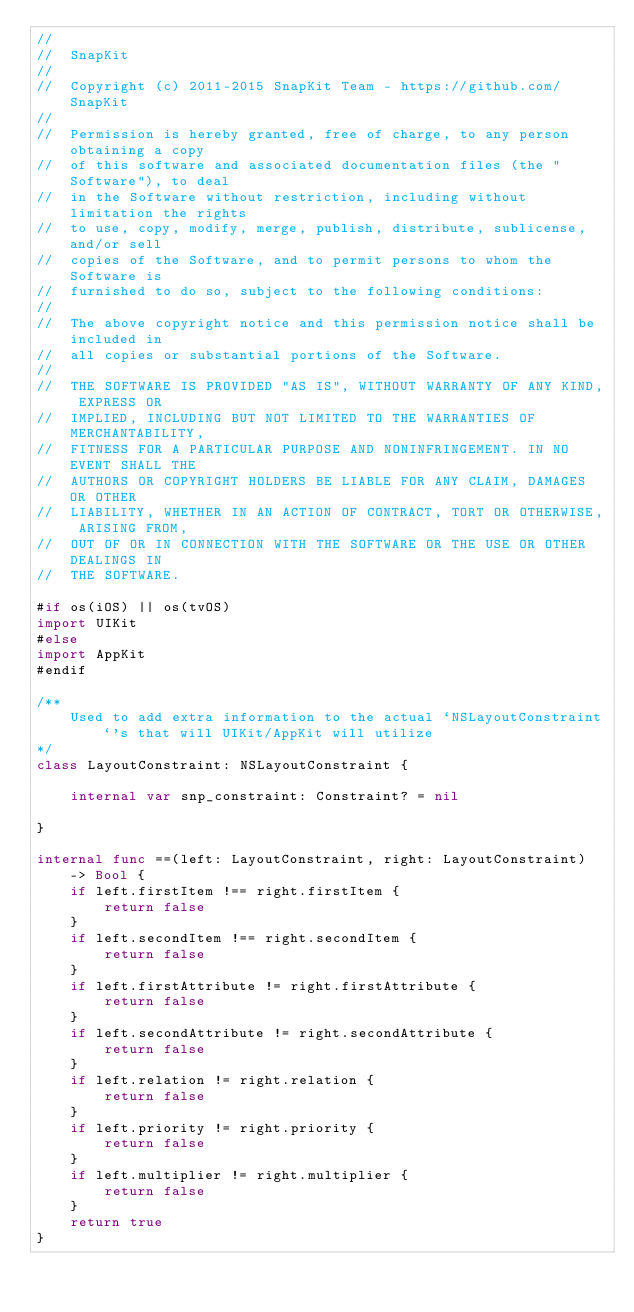Convert code to text. <code><loc_0><loc_0><loc_500><loc_500><_Swift_>//
//  SnapKit
//
//  Copyright (c) 2011-2015 SnapKit Team - https://github.com/SnapKit
//
//  Permission is hereby granted, free of charge, to any person obtaining a copy
//  of this software and associated documentation files (the "Software"), to deal
//  in the Software without restriction, including without limitation the rights
//  to use, copy, modify, merge, publish, distribute, sublicense, and/or sell
//  copies of the Software, and to permit persons to whom the Software is
//  furnished to do so, subject to the following conditions:
//
//  The above copyright notice and this permission notice shall be included in
//  all copies or substantial portions of the Software.
//
//  THE SOFTWARE IS PROVIDED "AS IS", WITHOUT WARRANTY OF ANY KIND, EXPRESS OR
//  IMPLIED, INCLUDING BUT NOT LIMITED TO THE WARRANTIES OF MERCHANTABILITY,
//  FITNESS FOR A PARTICULAR PURPOSE AND NONINFRINGEMENT. IN NO EVENT SHALL THE
//  AUTHORS OR COPYRIGHT HOLDERS BE LIABLE FOR ANY CLAIM, DAMAGES OR OTHER
//  LIABILITY, WHETHER IN AN ACTION OF CONTRACT, TORT OR OTHERWISE, ARISING FROM,
//  OUT OF OR IN CONNECTION WITH THE SOFTWARE OR THE USE OR OTHER DEALINGS IN
//  THE SOFTWARE.

#if os(iOS) || os(tvOS)
import UIKit
#else
import AppKit
#endif

/**
    Used to add extra information to the actual `NSLayoutConstraint`'s that will UIKit/AppKit will utilize
*/
class LayoutConstraint: NSLayoutConstraint {
    
    internal var snp_constraint: Constraint? = nil
    
}

internal func ==(left: LayoutConstraint, right: LayoutConstraint) -> Bool {
    if left.firstItem !== right.firstItem {
        return false
    }
    if left.secondItem !== right.secondItem {
        return false
    }
    if left.firstAttribute != right.firstAttribute {
        return false
    }
    if left.secondAttribute != right.secondAttribute {
        return false
    }
    if left.relation != right.relation {
        return false
    }
    if left.priority != right.priority {
        return false
    }
    if left.multiplier != right.multiplier {
        return false
    }
    return true
}

</code> 